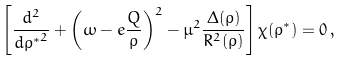Convert formula to latex. <formula><loc_0><loc_0><loc_500><loc_500>\left [ \frac { d ^ { 2 } } { { d { \rho } ^ { * } } ^ { 2 } } + \left ( \omega - e \frac { Q } { \rho } \right ) ^ { 2 } - \mu ^ { 2 } \frac { \Delta ( \rho ) } { R ^ { 2 } ( \rho ) } \right ] \chi ( { \rho } ^ { * } ) = 0 \, ,</formula> 